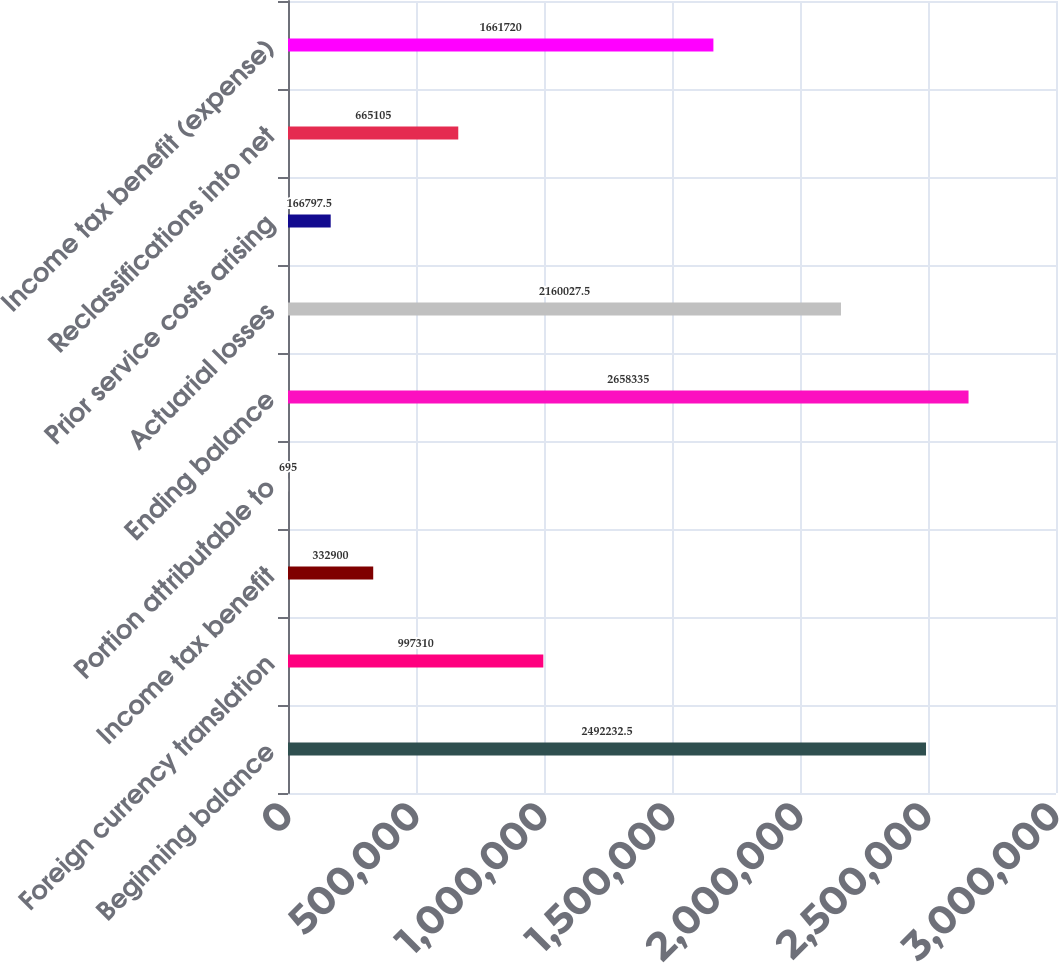Convert chart to OTSL. <chart><loc_0><loc_0><loc_500><loc_500><bar_chart><fcel>Beginning balance<fcel>Foreign currency translation<fcel>Income tax benefit<fcel>Portion attributable to<fcel>Ending balance<fcel>Actuarial losses<fcel>Prior service costs arising<fcel>Reclassifications into net<fcel>Income tax benefit (expense)<nl><fcel>2.49223e+06<fcel>997310<fcel>332900<fcel>695<fcel>2.65834e+06<fcel>2.16003e+06<fcel>166798<fcel>665105<fcel>1.66172e+06<nl></chart> 